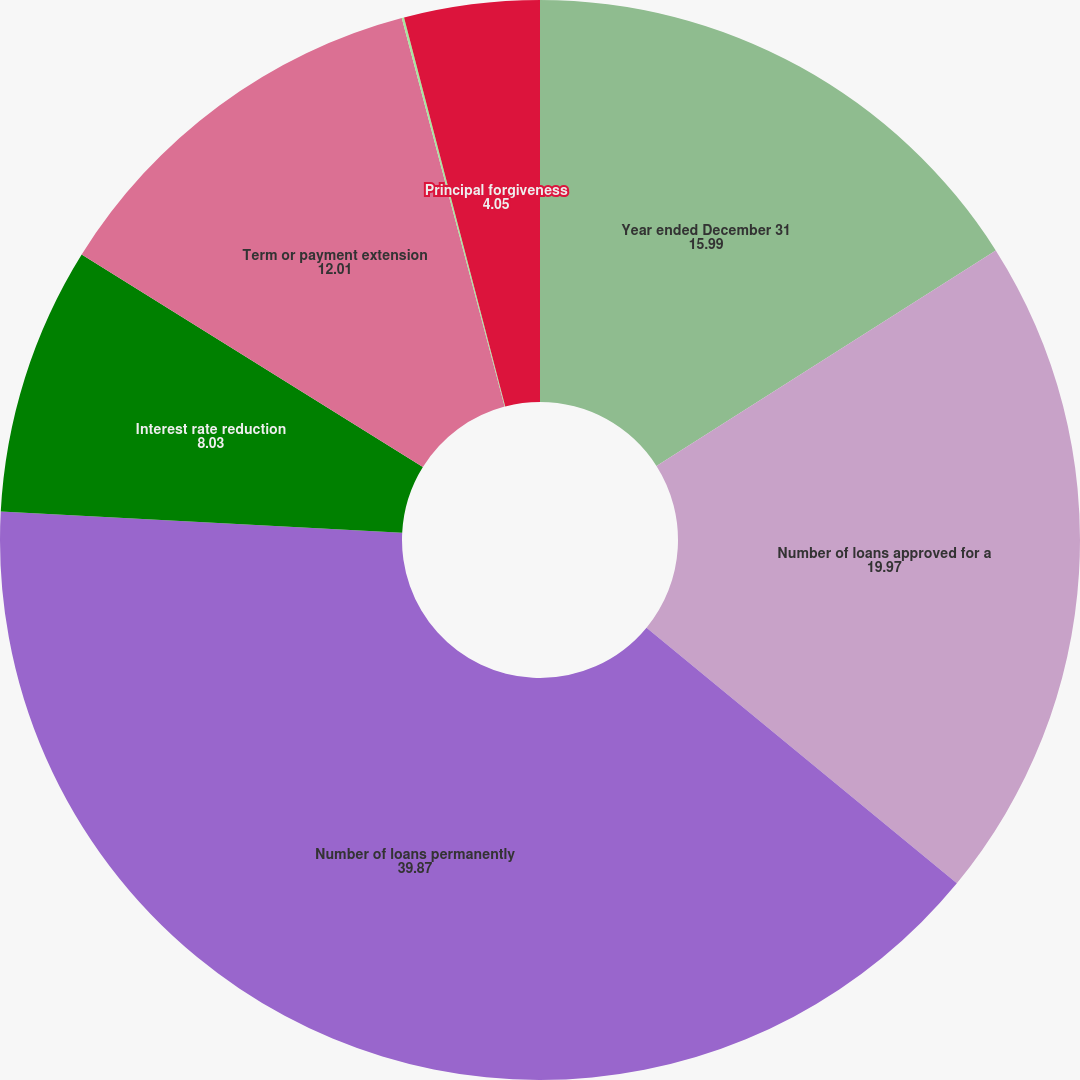<chart> <loc_0><loc_0><loc_500><loc_500><pie_chart><fcel>Year ended December 31<fcel>Number of loans approved for a<fcel>Number of loans permanently<fcel>Interest rate reduction<fcel>Term or payment extension<fcel>Principal and/or interest<fcel>Principal forgiveness<nl><fcel>15.99%<fcel>19.97%<fcel>39.87%<fcel>8.03%<fcel>12.01%<fcel>0.07%<fcel>4.05%<nl></chart> 